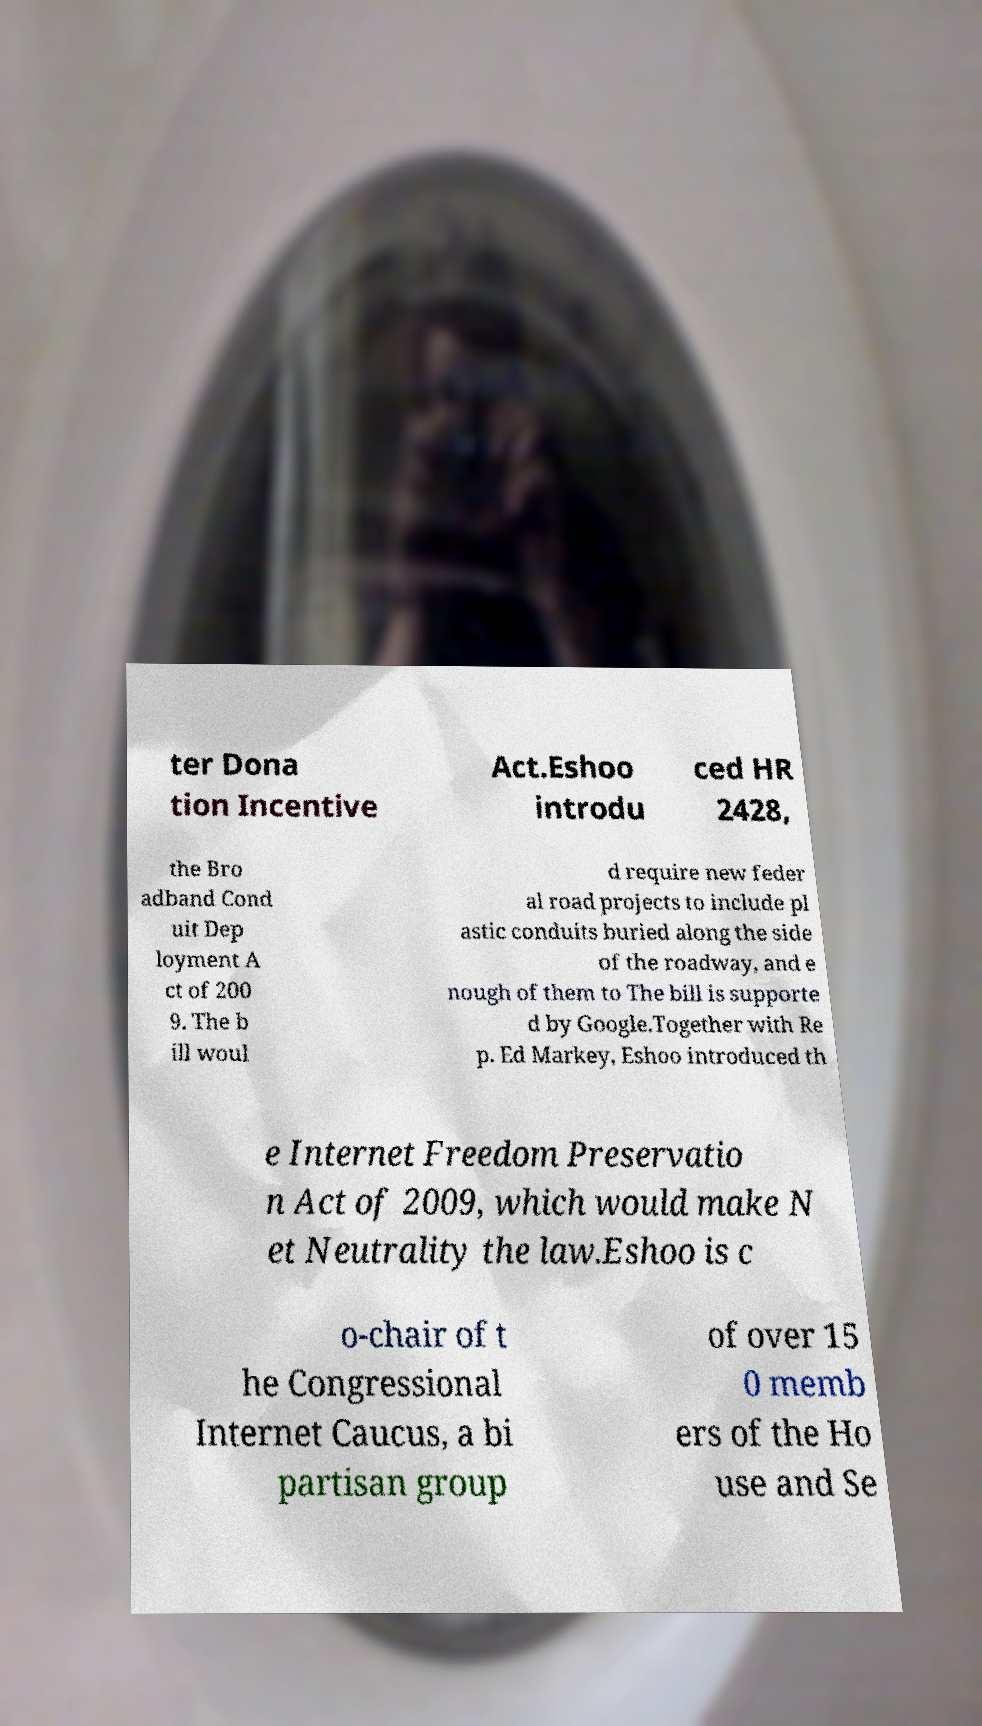Could you assist in decoding the text presented in this image and type it out clearly? ter Dona tion Incentive Act.Eshoo introdu ced HR 2428, the Bro adband Cond uit Dep loyment A ct of 200 9. The b ill woul d require new feder al road projects to include pl astic conduits buried along the side of the roadway, and e nough of them to The bill is supporte d by Google.Together with Re p. Ed Markey, Eshoo introduced th e Internet Freedom Preservatio n Act of 2009, which would make N et Neutrality the law.Eshoo is c o-chair of t he Congressional Internet Caucus, a bi partisan group of over 15 0 memb ers of the Ho use and Se 